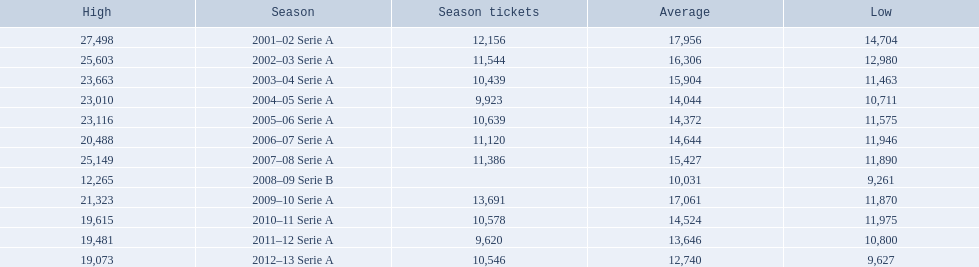When were all of the seasons? 2001–02 Serie A, 2002–03 Serie A, 2003–04 Serie A, 2004–05 Serie A, 2005–06 Serie A, 2006–07 Serie A, 2007–08 Serie A, 2008–09 Serie B, 2009–10 Serie A, 2010–11 Serie A, 2011–12 Serie A, 2012–13 Serie A. How many tickets were sold? 12,156, 11,544, 10,439, 9,923, 10,639, 11,120, 11,386, , 13,691, 10,578, 9,620, 10,546. What about just during the 2007 season? 11,386. 